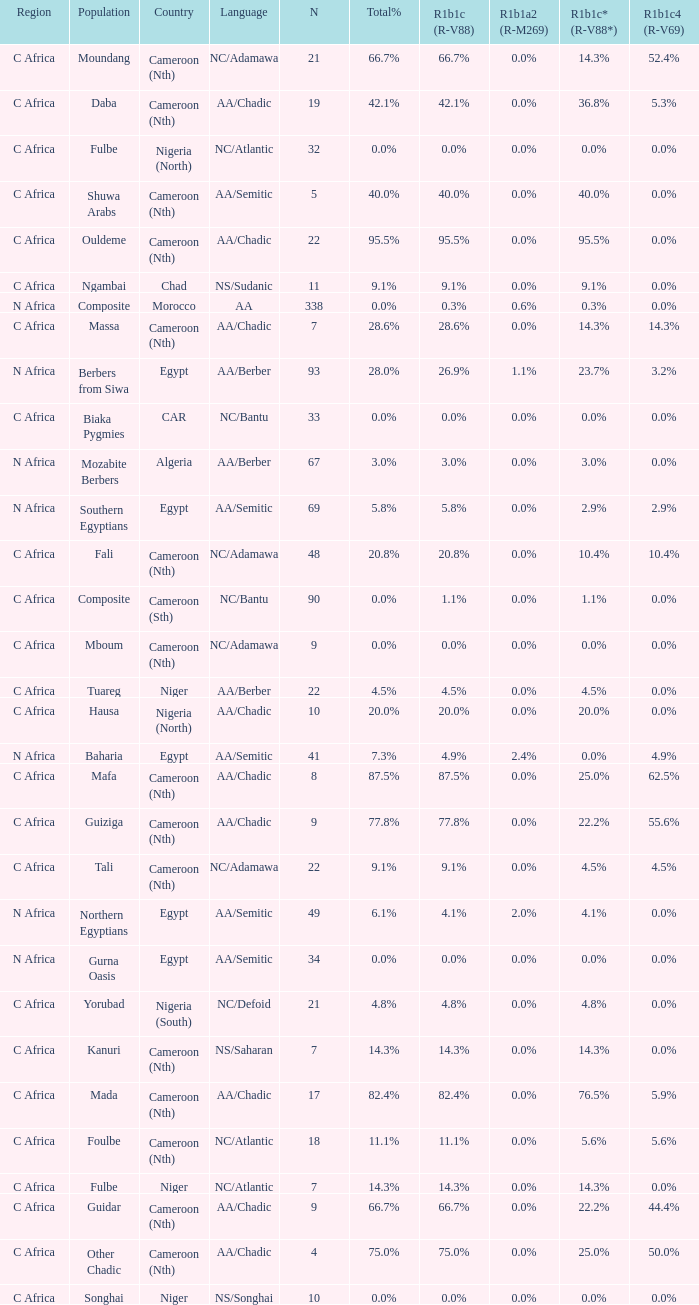What languages are spoken in Niger with r1b1c (r-v88) of 0.0%? NS/Songhai. 